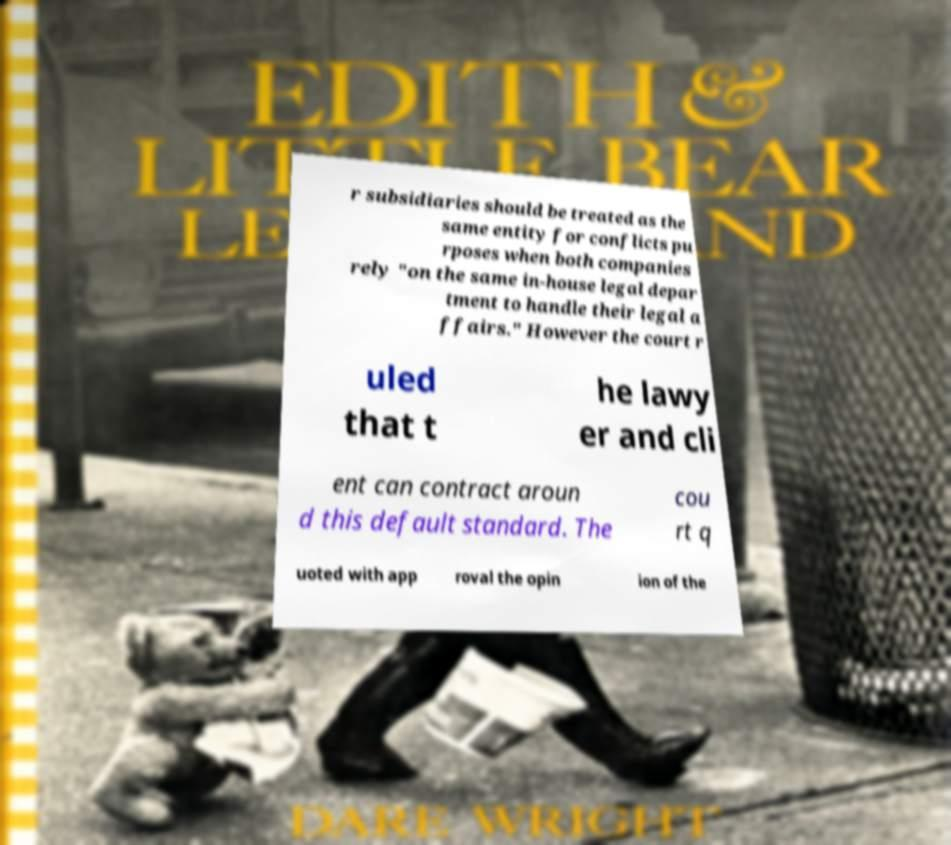For documentation purposes, I need the text within this image transcribed. Could you provide that? r subsidiaries should be treated as the same entity for conflicts pu rposes when both companies rely "on the same in-house legal depar tment to handle their legal a ffairs." However the court r uled that t he lawy er and cli ent can contract aroun d this default standard. The cou rt q uoted with app roval the opin ion of the 